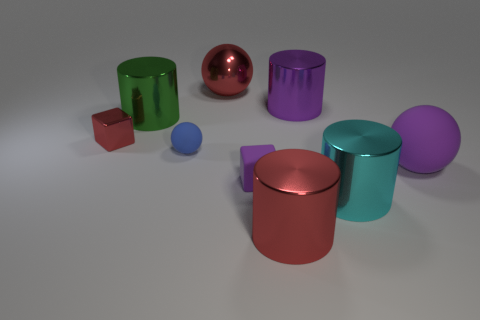Subtract 3 cylinders. How many cylinders are left? 1 Subtract all cyan cylinders. How many cylinders are left? 3 Subtract all big purple cylinders. How many cylinders are left? 3 Subtract all spheres. How many objects are left? 6 Subtract all purple balls. Subtract all brown cylinders. How many balls are left? 2 Subtract all cyan balls. How many red blocks are left? 1 Subtract all green metal cylinders. Subtract all blue objects. How many objects are left? 7 Add 8 red cylinders. How many red cylinders are left? 9 Add 5 large red metal cylinders. How many large red metal cylinders exist? 6 Subtract 1 red spheres. How many objects are left? 8 